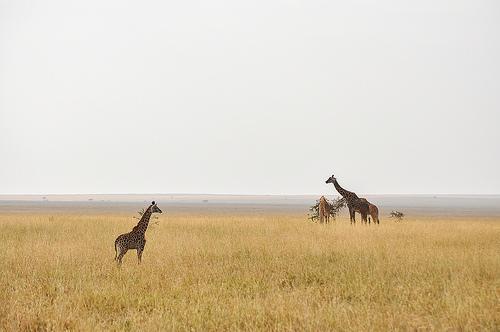How many giraffes are clearly visible?
Give a very brief answer. 2. 